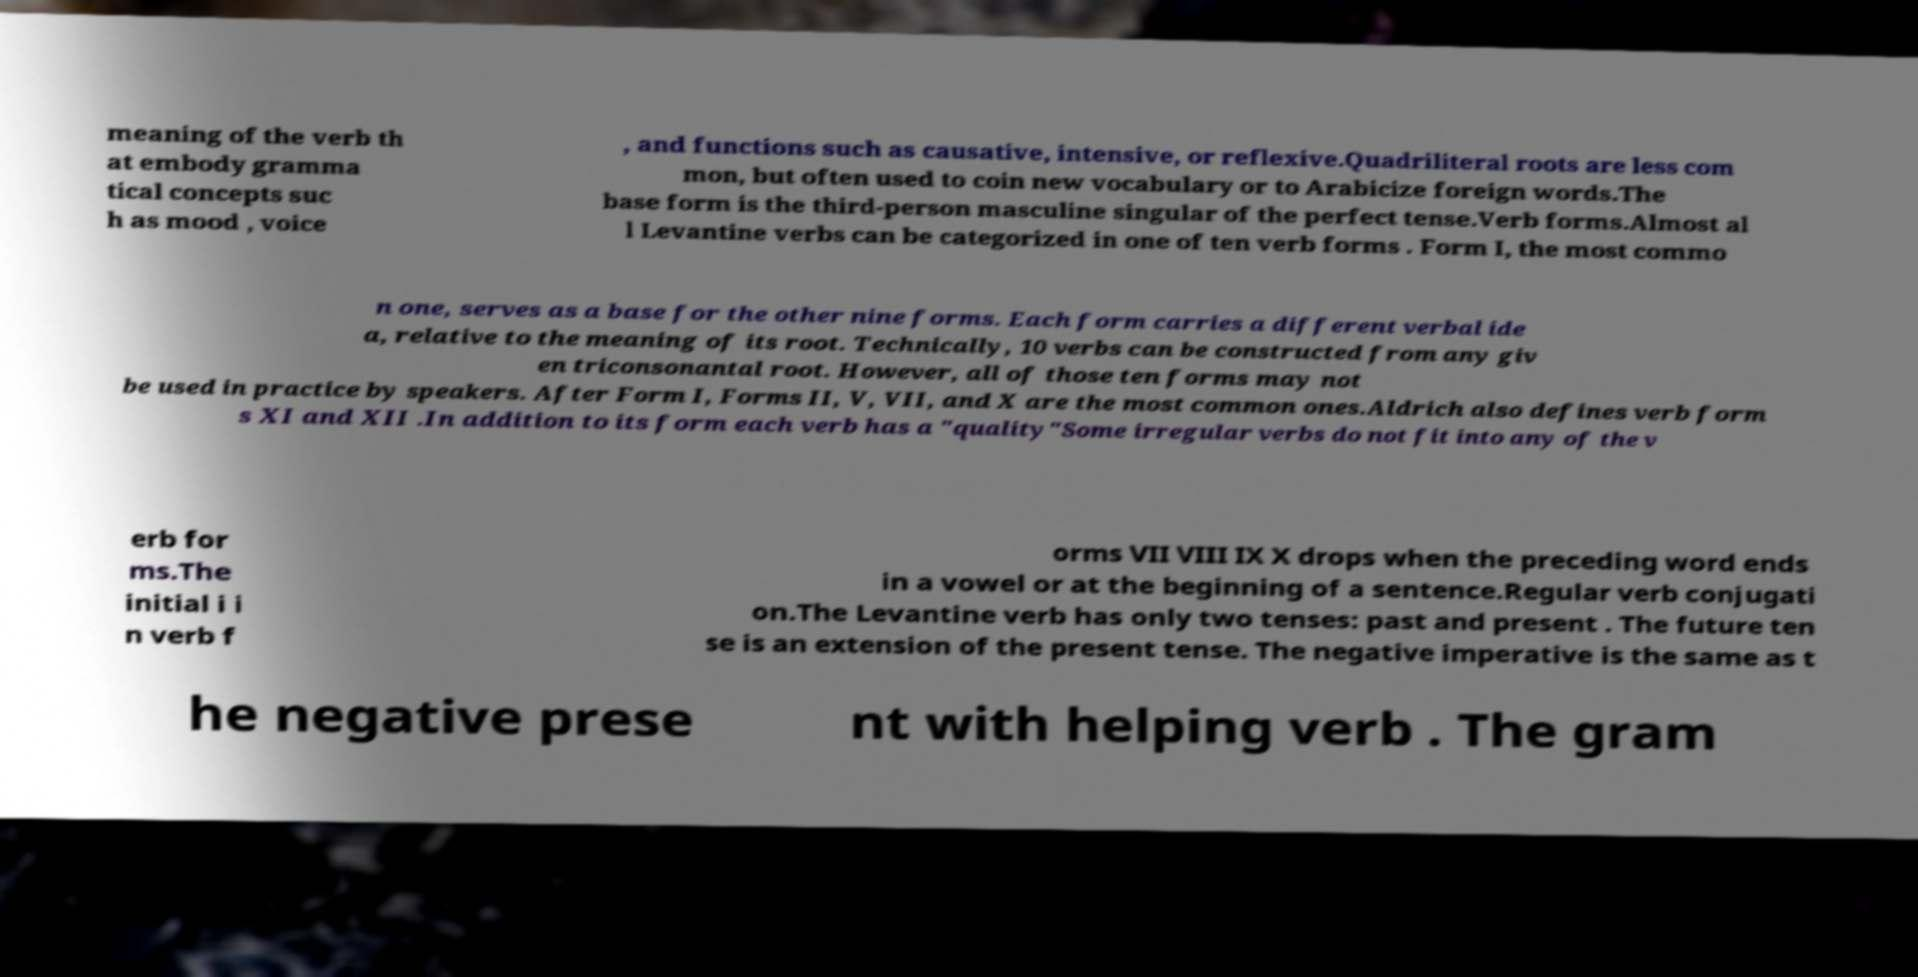Can you accurately transcribe the text from the provided image for me? meaning of the verb th at embody gramma tical concepts suc h as mood , voice , and functions such as causative, intensive, or reflexive.Quadriliteral roots are less com mon, but often used to coin new vocabulary or to Arabicize foreign words.The base form is the third-person masculine singular of the perfect tense.Verb forms.Almost al l Levantine verbs can be categorized in one of ten verb forms . Form I, the most commo n one, serves as a base for the other nine forms. Each form carries a different verbal ide a, relative to the meaning of its root. Technically, 10 verbs can be constructed from any giv en triconsonantal root. However, all of those ten forms may not be used in practice by speakers. After Form I, Forms II, V, VII, and X are the most common ones.Aldrich also defines verb form s XI and XII .In addition to its form each verb has a "quality"Some irregular verbs do not fit into any of the v erb for ms.The initial i i n verb f orms VII VIII IX X drops when the preceding word ends in a vowel or at the beginning of a sentence.Regular verb conjugati on.The Levantine verb has only two tenses: past and present . The future ten se is an extension of the present tense. The negative imperative is the same as t he negative prese nt with helping verb . The gram 